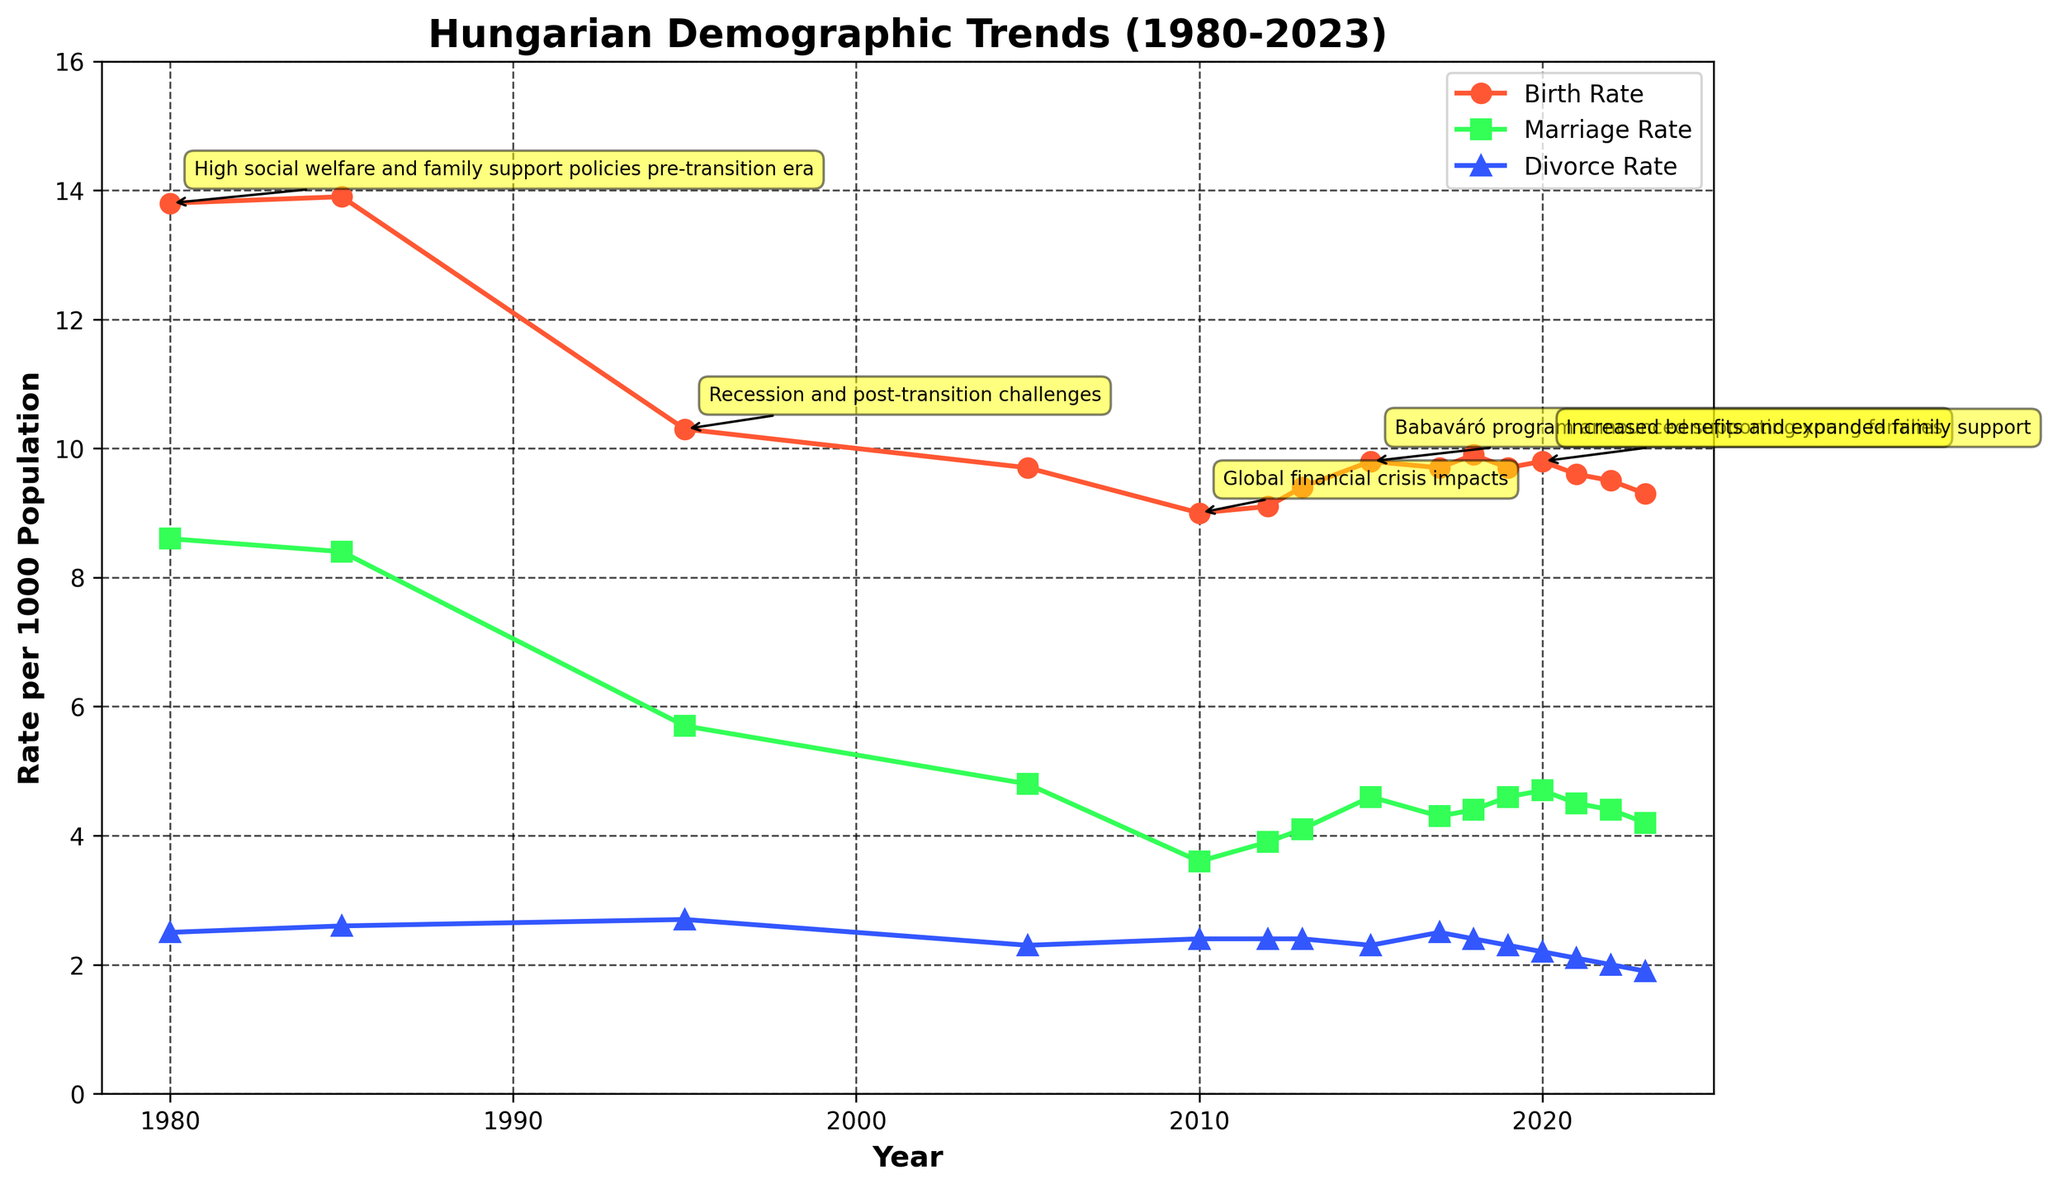What is the title of the figure? The title is usually located at the top of the figure, and it provides an overall description of what the figure is about. In this case, the title is "Hungarian Demographic Trends (1980-2023)."
Answer: Hungarian Demographic Trends (1980-2023) Which year had the highest birth rate? To find the highest birth rate, look at the peak of the birth rate line. The peak in the early period was in 1985 when the birth rate reached 13.9 per 1000 Population.
Answer: 1985 How did the divorce rate change between 2010 and 2013? Identify the points corresponding to 2010 and 2013 on the divorce rate line and observe the change. The divorce rate remained constant at 2.4 per 1000 Population during these years.
Answer: Remained constant What was the birth rate in 1995? Locate the year 1995 on the x-axis and follow it up to the birth rate line, which is marked as 10.3 per 1000 Population.
Answer: 10.3 per 1000 Population How did the marriage rate change from 2015 to 2020? Find the marriage rate values for 2015 and 2020 and observe the difference. In 2015, the rate was 4.6, and in 2020, it increased to 4.7 per 1000 Population. This shows a slight increase.
Answer: Increased Compare the birth and marriage rates in 2021. Were they equal? Compare the values of the birth rate and marriage rate in the year 2021. The birth rate was 9.6, and the marriage rate was 4.5, so they were not equal.
Answer: No Which government policy was introduced in 2015, and what impact did it have on birth and marriage rates? Label annotations indicate that in 2015, the Babaváró program was announced supporting young families. From 2015 onward, an increase in both birth and marriage rates can be observed.
Answer: Babaváró program, increased Calculate the average birth rate from 1980 to 2023. Sum the birth rates for each year and divide by the number of years. The sum is (13.8 + 13.9 + 10.3 + 9.7 + 9.0 + 9.1 + 9.4 + 9.8 + 9.7 + 9.9 + 9.7 + 9.8 + 9.6 + 9.5 + 9.3) = 142.5. The number of years is 15. Therefore, the average birth rate is 142.5 / 15 = 9.5.
Answer: 9.5 per 1000 Population 